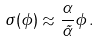Convert formula to latex. <formula><loc_0><loc_0><loc_500><loc_500>\sigma ( \phi ) \approx \frac { \alpha } { \tilde { \alpha } } \phi \, .</formula> 